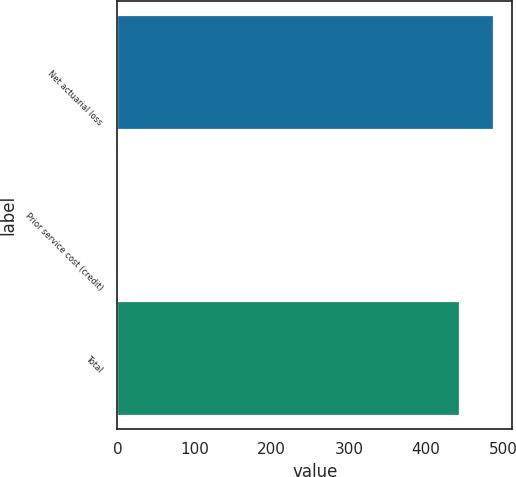Convert chart. <chart><loc_0><loc_0><loc_500><loc_500><bar_chart><fcel>Net actuarial loss<fcel>Prior service cost (credit)<fcel>Total<nl><fcel>487.15<fcel>1.1<fcel>442.9<nl></chart> 